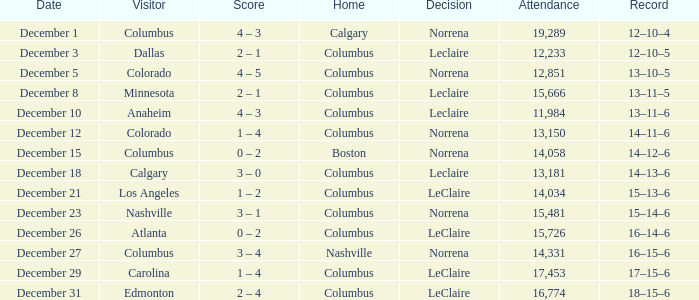What was the outcome with a 16-14-6 record? 0 – 2. 